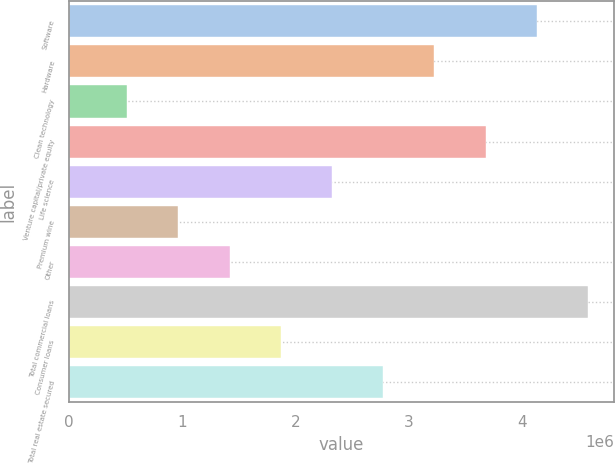Convert chart. <chart><loc_0><loc_0><loc_500><loc_500><bar_chart><fcel>Software<fcel>Hardware<fcel>Clean technology<fcel>Venture capital/private equity<fcel>Life science<fcel>Premium wine<fcel>Other<fcel>Total commercial loans<fcel>Consumer loans<fcel>Total real estate secured<nl><fcel>4.1307e+06<fcel>3.22618e+06<fcel>512599<fcel>3.67844e+06<fcel>2.32165e+06<fcel>964862<fcel>1.41712e+06<fcel>4.58297e+06<fcel>1.86939e+06<fcel>2.77391e+06<nl></chart> 